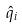<formula> <loc_0><loc_0><loc_500><loc_500>\hat { q } _ { i }</formula> 